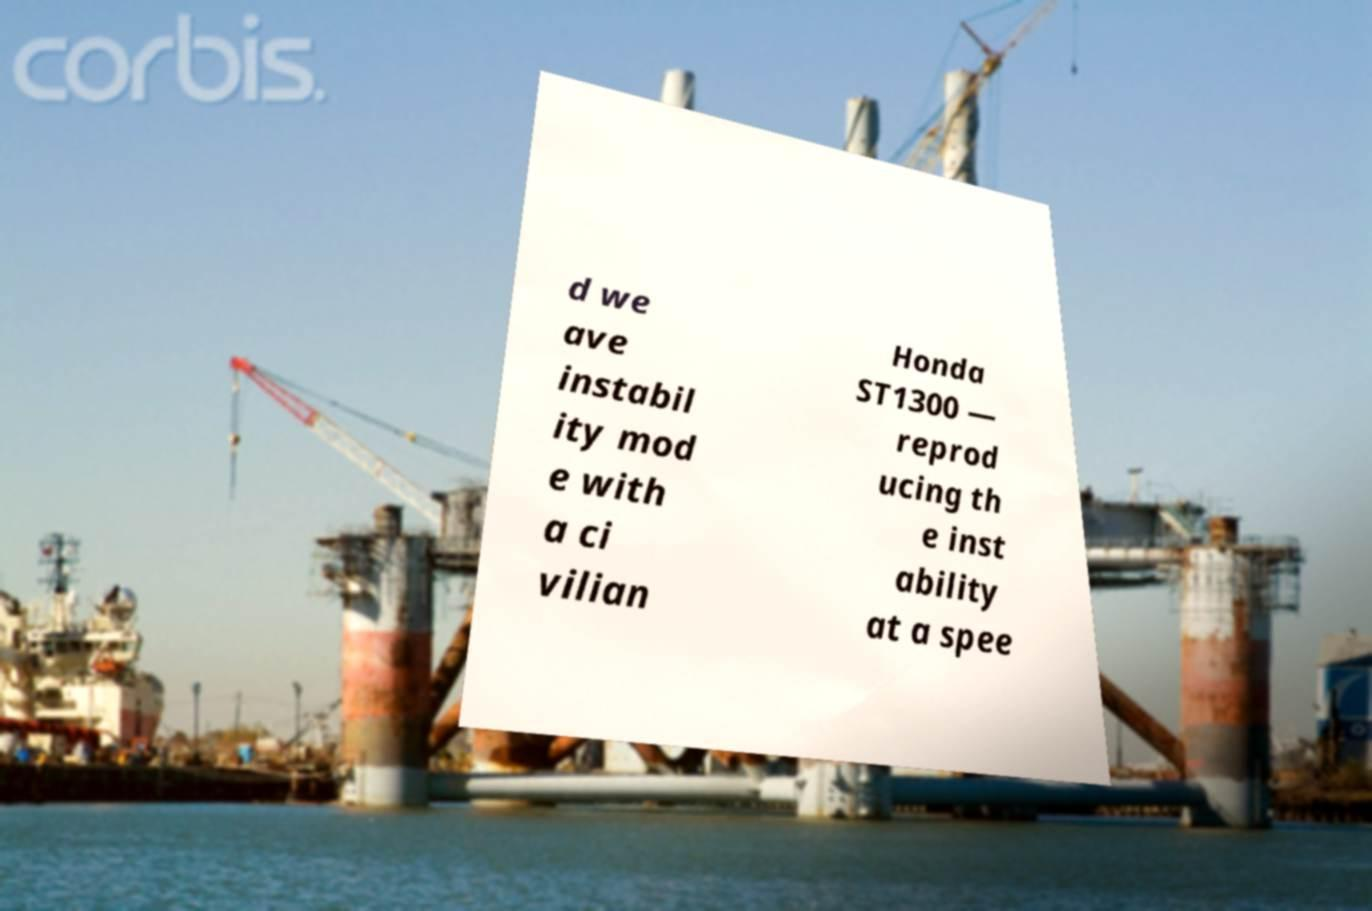Please read and relay the text visible in this image. What does it say? d we ave instabil ity mod e with a ci vilian Honda ST1300 — reprod ucing th e inst ability at a spee 